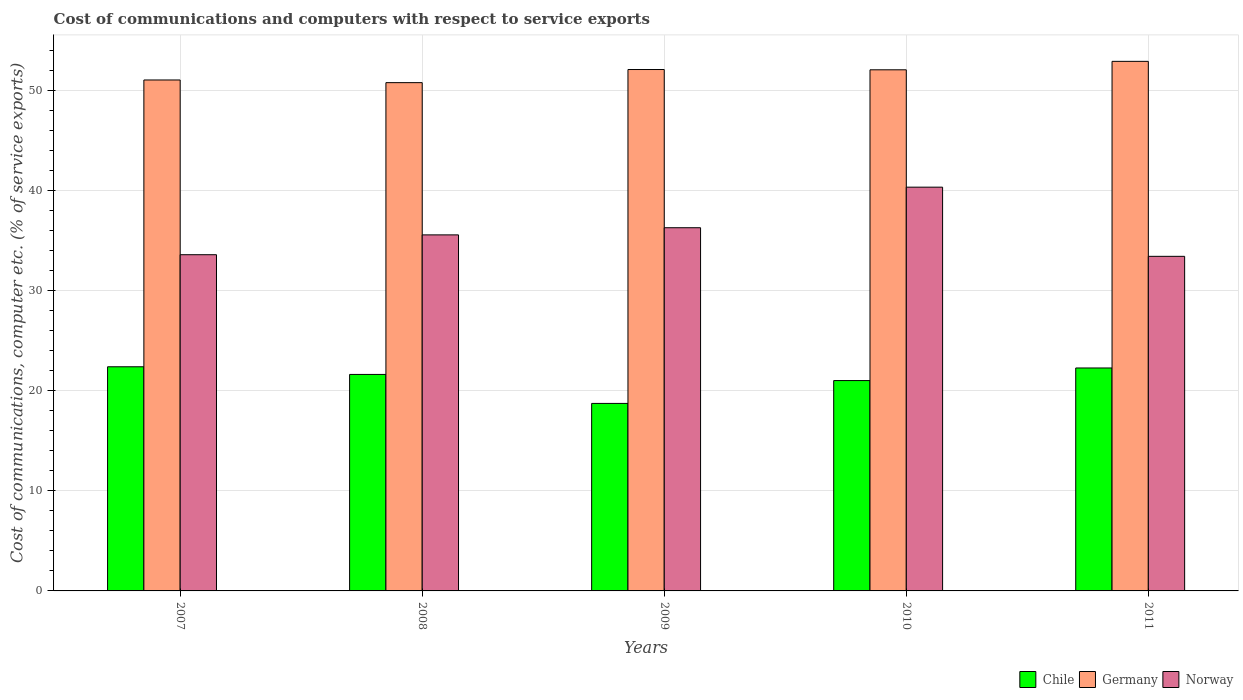Are the number of bars per tick equal to the number of legend labels?
Provide a short and direct response. Yes. How many bars are there on the 3rd tick from the left?
Give a very brief answer. 3. How many bars are there on the 2nd tick from the right?
Keep it short and to the point. 3. What is the label of the 1st group of bars from the left?
Your answer should be very brief. 2007. In how many cases, is the number of bars for a given year not equal to the number of legend labels?
Your answer should be compact. 0. What is the cost of communications and computers in Germany in 2007?
Ensure brevity in your answer.  51.06. Across all years, what is the maximum cost of communications and computers in Chile?
Offer a terse response. 22.4. Across all years, what is the minimum cost of communications and computers in Norway?
Your response must be concise. 33.44. In which year was the cost of communications and computers in Chile maximum?
Offer a terse response. 2007. In which year was the cost of communications and computers in Chile minimum?
Ensure brevity in your answer.  2009. What is the total cost of communications and computers in Chile in the graph?
Offer a terse response. 106.08. What is the difference between the cost of communications and computers in Germany in 2008 and that in 2009?
Offer a very short reply. -1.31. What is the difference between the cost of communications and computers in Chile in 2011 and the cost of communications and computers in Germany in 2009?
Make the answer very short. -29.83. What is the average cost of communications and computers in Germany per year?
Ensure brevity in your answer.  51.79. In the year 2009, what is the difference between the cost of communications and computers in Norway and cost of communications and computers in Chile?
Offer a terse response. 17.56. In how many years, is the cost of communications and computers in Norway greater than 20 %?
Give a very brief answer. 5. What is the ratio of the cost of communications and computers in Chile in 2007 to that in 2009?
Give a very brief answer. 1.2. Is the difference between the cost of communications and computers in Norway in 2008 and 2009 greater than the difference between the cost of communications and computers in Chile in 2008 and 2009?
Your response must be concise. No. What is the difference between the highest and the second highest cost of communications and computers in Germany?
Make the answer very short. 0.82. What is the difference between the highest and the lowest cost of communications and computers in Germany?
Your response must be concise. 2.13. What does the 1st bar from the left in 2010 represents?
Provide a short and direct response. Chile. How many bars are there?
Provide a short and direct response. 15. How many years are there in the graph?
Your answer should be very brief. 5. Does the graph contain any zero values?
Your answer should be compact. No. Does the graph contain grids?
Keep it short and to the point. Yes. Where does the legend appear in the graph?
Give a very brief answer. Bottom right. How many legend labels are there?
Provide a succinct answer. 3. What is the title of the graph?
Your answer should be very brief. Cost of communications and computers with respect to service exports. Does "Benin" appear as one of the legend labels in the graph?
Your answer should be compact. No. What is the label or title of the X-axis?
Offer a terse response. Years. What is the label or title of the Y-axis?
Offer a terse response. Cost of communications, computer etc. (% of service exports). What is the Cost of communications, computer etc. (% of service exports) in Chile in 2007?
Give a very brief answer. 22.4. What is the Cost of communications, computer etc. (% of service exports) in Germany in 2007?
Make the answer very short. 51.06. What is the Cost of communications, computer etc. (% of service exports) of Norway in 2007?
Your answer should be very brief. 33.6. What is the Cost of communications, computer etc. (% of service exports) of Chile in 2008?
Make the answer very short. 21.64. What is the Cost of communications, computer etc. (% of service exports) in Germany in 2008?
Your response must be concise. 50.8. What is the Cost of communications, computer etc. (% of service exports) of Norway in 2008?
Offer a very short reply. 35.58. What is the Cost of communications, computer etc. (% of service exports) in Chile in 2009?
Give a very brief answer. 18.74. What is the Cost of communications, computer etc. (% of service exports) in Germany in 2009?
Provide a short and direct response. 52.11. What is the Cost of communications, computer etc. (% of service exports) in Norway in 2009?
Your answer should be very brief. 36.3. What is the Cost of communications, computer etc. (% of service exports) of Chile in 2010?
Make the answer very short. 21.02. What is the Cost of communications, computer etc. (% of service exports) in Germany in 2010?
Give a very brief answer. 52.08. What is the Cost of communications, computer etc. (% of service exports) of Norway in 2010?
Provide a succinct answer. 40.35. What is the Cost of communications, computer etc. (% of service exports) in Chile in 2011?
Provide a short and direct response. 22.28. What is the Cost of communications, computer etc. (% of service exports) in Germany in 2011?
Give a very brief answer. 52.92. What is the Cost of communications, computer etc. (% of service exports) in Norway in 2011?
Give a very brief answer. 33.44. Across all years, what is the maximum Cost of communications, computer etc. (% of service exports) of Chile?
Your response must be concise. 22.4. Across all years, what is the maximum Cost of communications, computer etc. (% of service exports) in Germany?
Offer a terse response. 52.92. Across all years, what is the maximum Cost of communications, computer etc. (% of service exports) in Norway?
Your answer should be compact. 40.35. Across all years, what is the minimum Cost of communications, computer etc. (% of service exports) of Chile?
Provide a short and direct response. 18.74. Across all years, what is the minimum Cost of communications, computer etc. (% of service exports) in Germany?
Your response must be concise. 50.8. Across all years, what is the minimum Cost of communications, computer etc. (% of service exports) in Norway?
Ensure brevity in your answer.  33.44. What is the total Cost of communications, computer etc. (% of service exports) of Chile in the graph?
Your answer should be compact. 106.08. What is the total Cost of communications, computer etc. (% of service exports) in Germany in the graph?
Your response must be concise. 258.97. What is the total Cost of communications, computer etc. (% of service exports) of Norway in the graph?
Offer a very short reply. 179.27. What is the difference between the Cost of communications, computer etc. (% of service exports) in Chile in 2007 and that in 2008?
Your response must be concise. 0.77. What is the difference between the Cost of communications, computer etc. (% of service exports) in Germany in 2007 and that in 2008?
Give a very brief answer. 0.27. What is the difference between the Cost of communications, computer etc. (% of service exports) of Norway in 2007 and that in 2008?
Ensure brevity in your answer.  -1.98. What is the difference between the Cost of communications, computer etc. (% of service exports) of Chile in 2007 and that in 2009?
Your answer should be compact. 3.66. What is the difference between the Cost of communications, computer etc. (% of service exports) of Germany in 2007 and that in 2009?
Make the answer very short. -1.04. What is the difference between the Cost of communications, computer etc. (% of service exports) in Norway in 2007 and that in 2009?
Provide a short and direct response. -2.7. What is the difference between the Cost of communications, computer etc. (% of service exports) in Chile in 2007 and that in 2010?
Give a very brief answer. 1.38. What is the difference between the Cost of communications, computer etc. (% of service exports) of Germany in 2007 and that in 2010?
Give a very brief answer. -1.02. What is the difference between the Cost of communications, computer etc. (% of service exports) of Norway in 2007 and that in 2010?
Offer a very short reply. -6.75. What is the difference between the Cost of communications, computer etc. (% of service exports) in Chile in 2007 and that in 2011?
Your answer should be very brief. 0.12. What is the difference between the Cost of communications, computer etc. (% of service exports) of Germany in 2007 and that in 2011?
Your answer should be very brief. -1.86. What is the difference between the Cost of communications, computer etc. (% of service exports) in Norway in 2007 and that in 2011?
Make the answer very short. 0.16. What is the difference between the Cost of communications, computer etc. (% of service exports) in Chile in 2008 and that in 2009?
Provide a short and direct response. 2.9. What is the difference between the Cost of communications, computer etc. (% of service exports) in Germany in 2008 and that in 2009?
Your answer should be very brief. -1.31. What is the difference between the Cost of communications, computer etc. (% of service exports) in Norway in 2008 and that in 2009?
Offer a very short reply. -0.71. What is the difference between the Cost of communications, computer etc. (% of service exports) of Chile in 2008 and that in 2010?
Your answer should be very brief. 0.61. What is the difference between the Cost of communications, computer etc. (% of service exports) of Germany in 2008 and that in 2010?
Give a very brief answer. -1.28. What is the difference between the Cost of communications, computer etc. (% of service exports) in Norway in 2008 and that in 2010?
Offer a terse response. -4.77. What is the difference between the Cost of communications, computer etc. (% of service exports) in Chile in 2008 and that in 2011?
Ensure brevity in your answer.  -0.65. What is the difference between the Cost of communications, computer etc. (% of service exports) of Germany in 2008 and that in 2011?
Make the answer very short. -2.13. What is the difference between the Cost of communications, computer etc. (% of service exports) in Norway in 2008 and that in 2011?
Make the answer very short. 2.14. What is the difference between the Cost of communications, computer etc. (% of service exports) in Chile in 2009 and that in 2010?
Your answer should be very brief. -2.28. What is the difference between the Cost of communications, computer etc. (% of service exports) in Germany in 2009 and that in 2010?
Offer a very short reply. 0.03. What is the difference between the Cost of communications, computer etc. (% of service exports) of Norway in 2009 and that in 2010?
Offer a terse response. -4.05. What is the difference between the Cost of communications, computer etc. (% of service exports) of Chile in 2009 and that in 2011?
Offer a terse response. -3.54. What is the difference between the Cost of communications, computer etc. (% of service exports) in Germany in 2009 and that in 2011?
Provide a succinct answer. -0.82. What is the difference between the Cost of communications, computer etc. (% of service exports) in Norway in 2009 and that in 2011?
Offer a very short reply. 2.86. What is the difference between the Cost of communications, computer etc. (% of service exports) in Chile in 2010 and that in 2011?
Provide a succinct answer. -1.26. What is the difference between the Cost of communications, computer etc. (% of service exports) of Germany in 2010 and that in 2011?
Your answer should be very brief. -0.85. What is the difference between the Cost of communications, computer etc. (% of service exports) of Norway in 2010 and that in 2011?
Your answer should be very brief. 6.91. What is the difference between the Cost of communications, computer etc. (% of service exports) of Chile in 2007 and the Cost of communications, computer etc. (% of service exports) of Germany in 2008?
Provide a short and direct response. -28.4. What is the difference between the Cost of communications, computer etc. (% of service exports) in Chile in 2007 and the Cost of communications, computer etc. (% of service exports) in Norway in 2008?
Make the answer very short. -13.18. What is the difference between the Cost of communications, computer etc. (% of service exports) of Germany in 2007 and the Cost of communications, computer etc. (% of service exports) of Norway in 2008?
Give a very brief answer. 15.48. What is the difference between the Cost of communications, computer etc. (% of service exports) of Chile in 2007 and the Cost of communications, computer etc. (% of service exports) of Germany in 2009?
Provide a short and direct response. -29.71. What is the difference between the Cost of communications, computer etc. (% of service exports) of Chile in 2007 and the Cost of communications, computer etc. (% of service exports) of Norway in 2009?
Your answer should be very brief. -13.9. What is the difference between the Cost of communications, computer etc. (% of service exports) of Germany in 2007 and the Cost of communications, computer etc. (% of service exports) of Norway in 2009?
Your answer should be compact. 14.77. What is the difference between the Cost of communications, computer etc. (% of service exports) in Chile in 2007 and the Cost of communications, computer etc. (% of service exports) in Germany in 2010?
Keep it short and to the point. -29.68. What is the difference between the Cost of communications, computer etc. (% of service exports) in Chile in 2007 and the Cost of communications, computer etc. (% of service exports) in Norway in 2010?
Your response must be concise. -17.95. What is the difference between the Cost of communications, computer etc. (% of service exports) of Germany in 2007 and the Cost of communications, computer etc. (% of service exports) of Norway in 2010?
Your answer should be very brief. 10.71. What is the difference between the Cost of communications, computer etc. (% of service exports) of Chile in 2007 and the Cost of communications, computer etc. (% of service exports) of Germany in 2011?
Keep it short and to the point. -30.52. What is the difference between the Cost of communications, computer etc. (% of service exports) of Chile in 2007 and the Cost of communications, computer etc. (% of service exports) of Norway in 2011?
Your answer should be very brief. -11.04. What is the difference between the Cost of communications, computer etc. (% of service exports) in Germany in 2007 and the Cost of communications, computer etc. (% of service exports) in Norway in 2011?
Offer a very short reply. 17.62. What is the difference between the Cost of communications, computer etc. (% of service exports) of Chile in 2008 and the Cost of communications, computer etc. (% of service exports) of Germany in 2009?
Offer a very short reply. -30.47. What is the difference between the Cost of communications, computer etc. (% of service exports) in Chile in 2008 and the Cost of communications, computer etc. (% of service exports) in Norway in 2009?
Offer a terse response. -14.66. What is the difference between the Cost of communications, computer etc. (% of service exports) of Chile in 2008 and the Cost of communications, computer etc. (% of service exports) of Germany in 2010?
Keep it short and to the point. -30.44. What is the difference between the Cost of communications, computer etc. (% of service exports) in Chile in 2008 and the Cost of communications, computer etc. (% of service exports) in Norway in 2010?
Make the answer very short. -18.71. What is the difference between the Cost of communications, computer etc. (% of service exports) in Germany in 2008 and the Cost of communications, computer etc. (% of service exports) in Norway in 2010?
Your answer should be compact. 10.45. What is the difference between the Cost of communications, computer etc. (% of service exports) of Chile in 2008 and the Cost of communications, computer etc. (% of service exports) of Germany in 2011?
Make the answer very short. -31.29. What is the difference between the Cost of communications, computer etc. (% of service exports) of Chile in 2008 and the Cost of communications, computer etc. (% of service exports) of Norway in 2011?
Provide a short and direct response. -11.8. What is the difference between the Cost of communications, computer etc. (% of service exports) in Germany in 2008 and the Cost of communications, computer etc. (% of service exports) in Norway in 2011?
Make the answer very short. 17.36. What is the difference between the Cost of communications, computer etc. (% of service exports) of Chile in 2009 and the Cost of communications, computer etc. (% of service exports) of Germany in 2010?
Keep it short and to the point. -33.34. What is the difference between the Cost of communications, computer etc. (% of service exports) of Chile in 2009 and the Cost of communications, computer etc. (% of service exports) of Norway in 2010?
Ensure brevity in your answer.  -21.61. What is the difference between the Cost of communications, computer etc. (% of service exports) in Germany in 2009 and the Cost of communications, computer etc. (% of service exports) in Norway in 2010?
Your answer should be very brief. 11.76. What is the difference between the Cost of communications, computer etc. (% of service exports) of Chile in 2009 and the Cost of communications, computer etc. (% of service exports) of Germany in 2011?
Make the answer very short. -34.19. What is the difference between the Cost of communications, computer etc. (% of service exports) of Chile in 2009 and the Cost of communications, computer etc. (% of service exports) of Norway in 2011?
Your response must be concise. -14.7. What is the difference between the Cost of communications, computer etc. (% of service exports) of Germany in 2009 and the Cost of communications, computer etc. (% of service exports) of Norway in 2011?
Give a very brief answer. 18.67. What is the difference between the Cost of communications, computer etc. (% of service exports) of Chile in 2010 and the Cost of communications, computer etc. (% of service exports) of Germany in 2011?
Offer a terse response. -31.9. What is the difference between the Cost of communications, computer etc. (% of service exports) of Chile in 2010 and the Cost of communications, computer etc. (% of service exports) of Norway in 2011?
Keep it short and to the point. -12.42. What is the difference between the Cost of communications, computer etc. (% of service exports) in Germany in 2010 and the Cost of communications, computer etc. (% of service exports) in Norway in 2011?
Your answer should be compact. 18.64. What is the average Cost of communications, computer etc. (% of service exports) of Chile per year?
Provide a succinct answer. 21.22. What is the average Cost of communications, computer etc. (% of service exports) in Germany per year?
Offer a very short reply. 51.79. What is the average Cost of communications, computer etc. (% of service exports) of Norway per year?
Your answer should be compact. 35.85. In the year 2007, what is the difference between the Cost of communications, computer etc. (% of service exports) in Chile and Cost of communications, computer etc. (% of service exports) in Germany?
Give a very brief answer. -28.66. In the year 2007, what is the difference between the Cost of communications, computer etc. (% of service exports) of Chile and Cost of communications, computer etc. (% of service exports) of Norway?
Offer a very short reply. -11.2. In the year 2007, what is the difference between the Cost of communications, computer etc. (% of service exports) of Germany and Cost of communications, computer etc. (% of service exports) of Norway?
Your response must be concise. 17.46. In the year 2008, what is the difference between the Cost of communications, computer etc. (% of service exports) in Chile and Cost of communications, computer etc. (% of service exports) in Germany?
Give a very brief answer. -29.16. In the year 2008, what is the difference between the Cost of communications, computer etc. (% of service exports) in Chile and Cost of communications, computer etc. (% of service exports) in Norway?
Your answer should be compact. -13.95. In the year 2008, what is the difference between the Cost of communications, computer etc. (% of service exports) of Germany and Cost of communications, computer etc. (% of service exports) of Norway?
Provide a short and direct response. 15.21. In the year 2009, what is the difference between the Cost of communications, computer etc. (% of service exports) of Chile and Cost of communications, computer etc. (% of service exports) of Germany?
Your answer should be very brief. -33.37. In the year 2009, what is the difference between the Cost of communications, computer etc. (% of service exports) in Chile and Cost of communications, computer etc. (% of service exports) in Norway?
Your response must be concise. -17.56. In the year 2009, what is the difference between the Cost of communications, computer etc. (% of service exports) of Germany and Cost of communications, computer etc. (% of service exports) of Norway?
Your response must be concise. 15.81. In the year 2010, what is the difference between the Cost of communications, computer etc. (% of service exports) in Chile and Cost of communications, computer etc. (% of service exports) in Germany?
Ensure brevity in your answer.  -31.06. In the year 2010, what is the difference between the Cost of communications, computer etc. (% of service exports) of Chile and Cost of communications, computer etc. (% of service exports) of Norway?
Your response must be concise. -19.33. In the year 2010, what is the difference between the Cost of communications, computer etc. (% of service exports) in Germany and Cost of communications, computer etc. (% of service exports) in Norway?
Make the answer very short. 11.73. In the year 2011, what is the difference between the Cost of communications, computer etc. (% of service exports) in Chile and Cost of communications, computer etc. (% of service exports) in Germany?
Provide a succinct answer. -30.64. In the year 2011, what is the difference between the Cost of communications, computer etc. (% of service exports) of Chile and Cost of communications, computer etc. (% of service exports) of Norway?
Your response must be concise. -11.16. In the year 2011, what is the difference between the Cost of communications, computer etc. (% of service exports) of Germany and Cost of communications, computer etc. (% of service exports) of Norway?
Ensure brevity in your answer.  19.49. What is the ratio of the Cost of communications, computer etc. (% of service exports) in Chile in 2007 to that in 2008?
Your answer should be very brief. 1.04. What is the ratio of the Cost of communications, computer etc. (% of service exports) of Germany in 2007 to that in 2008?
Provide a short and direct response. 1.01. What is the ratio of the Cost of communications, computer etc. (% of service exports) in Norway in 2007 to that in 2008?
Your answer should be very brief. 0.94. What is the ratio of the Cost of communications, computer etc. (% of service exports) of Chile in 2007 to that in 2009?
Offer a very short reply. 1.2. What is the ratio of the Cost of communications, computer etc. (% of service exports) in Germany in 2007 to that in 2009?
Provide a short and direct response. 0.98. What is the ratio of the Cost of communications, computer etc. (% of service exports) of Norway in 2007 to that in 2009?
Keep it short and to the point. 0.93. What is the ratio of the Cost of communications, computer etc. (% of service exports) of Chile in 2007 to that in 2010?
Your response must be concise. 1.07. What is the ratio of the Cost of communications, computer etc. (% of service exports) of Germany in 2007 to that in 2010?
Your response must be concise. 0.98. What is the ratio of the Cost of communications, computer etc. (% of service exports) of Norway in 2007 to that in 2010?
Offer a very short reply. 0.83. What is the ratio of the Cost of communications, computer etc. (% of service exports) in Chile in 2007 to that in 2011?
Provide a short and direct response. 1.01. What is the ratio of the Cost of communications, computer etc. (% of service exports) in Germany in 2007 to that in 2011?
Offer a very short reply. 0.96. What is the ratio of the Cost of communications, computer etc. (% of service exports) of Norway in 2007 to that in 2011?
Make the answer very short. 1. What is the ratio of the Cost of communications, computer etc. (% of service exports) of Chile in 2008 to that in 2009?
Your answer should be compact. 1.15. What is the ratio of the Cost of communications, computer etc. (% of service exports) in Germany in 2008 to that in 2009?
Keep it short and to the point. 0.97. What is the ratio of the Cost of communications, computer etc. (% of service exports) in Norway in 2008 to that in 2009?
Provide a short and direct response. 0.98. What is the ratio of the Cost of communications, computer etc. (% of service exports) in Chile in 2008 to that in 2010?
Your response must be concise. 1.03. What is the ratio of the Cost of communications, computer etc. (% of service exports) of Germany in 2008 to that in 2010?
Make the answer very short. 0.98. What is the ratio of the Cost of communications, computer etc. (% of service exports) of Norway in 2008 to that in 2010?
Provide a short and direct response. 0.88. What is the ratio of the Cost of communications, computer etc. (% of service exports) in Chile in 2008 to that in 2011?
Keep it short and to the point. 0.97. What is the ratio of the Cost of communications, computer etc. (% of service exports) in Germany in 2008 to that in 2011?
Keep it short and to the point. 0.96. What is the ratio of the Cost of communications, computer etc. (% of service exports) in Norway in 2008 to that in 2011?
Provide a succinct answer. 1.06. What is the ratio of the Cost of communications, computer etc. (% of service exports) in Chile in 2009 to that in 2010?
Your answer should be compact. 0.89. What is the ratio of the Cost of communications, computer etc. (% of service exports) of Norway in 2009 to that in 2010?
Offer a terse response. 0.9. What is the ratio of the Cost of communications, computer etc. (% of service exports) in Chile in 2009 to that in 2011?
Ensure brevity in your answer.  0.84. What is the ratio of the Cost of communications, computer etc. (% of service exports) in Germany in 2009 to that in 2011?
Your answer should be compact. 0.98. What is the ratio of the Cost of communications, computer etc. (% of service exports) in Norway in 2009 to that in 2011?
Make the answer very short. 1.09. What is the ratio of the Cost of communications, computer etc. (% of service exports) in Chile in 2010 to that in 2011?
Offer a terse response. 0.94. What is the ratio of the Cost of communications, computer etc. (% of service exports) in Norway in 2010 to that in 2011?
Your answer should be very brief. 1.21. What is the difference between the highest and the second highest Cost of communications, computer etc. (% of service exports) of Chile?
Make the answer very short. 0.12. What is the difference between the highest and the second highest Cost of communications, computer etc. (% of service exports) of Germany?
Provide a short and direct response. 0.82. What is the difference between the highest and the second highest Cost of communications, computer etc. (% of service exports) of Norway?
Ensure brevity in your answer.  4.05. What is the difference between the highest and the lowest Cost of communications, computer etc. (% of service exports) in Chile?
Ensure brevity in your answer.  3.66. What is the difference between the highest and the lowest Cost of communications, computer etc. (% of service exports) of Germany?
Ensure brevity in your answer.  2.13. What is the difference between the highest and the lowest Cost of communications, computer etc. (% of service exports) of Norway?
Your response must be concise. 6.91. 